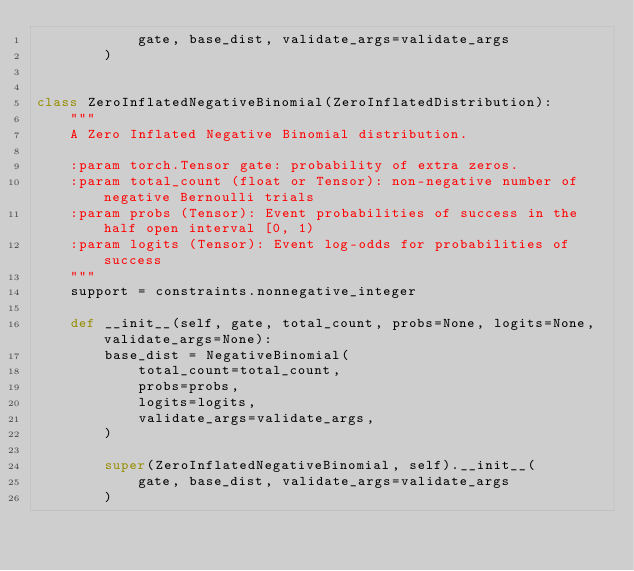Convert code to text. <code><loc_0><loc_0><loc_500><loc_500><_Python_>            gate, base_dist, validate_args=validate_args
        )


class ZeroInflatedNegativeBinomial(ZeroInflatedDistribution):
    """
    A Zero Inflated Negative Binomial distribution.

    :param torch.Tensor gate: probability of extra zeros.
    :param total_count (float or Tensor): non-negative number of negative Bernoulli trials
    :param probs (Tensor): Event probabilities of success in the half open interval [0, 1)
    :param logits (Tensor): Event log-odds for probabilities of success
    """
    support = constraints.nonnegative_integer

    def __init__(self, gate, total_count, probs=None, logits=None, validate_args=None):
        base_dist = NegativeBinomial(
            total_count=total_count,
            probs=probs,
            logits=logits,
            validate_args=validate_args,
        )

        super(ZeroInflatedNegativeBinomial, self).__init__(
            gate, base_dist, validate_args=validate_args
        )
</code> 